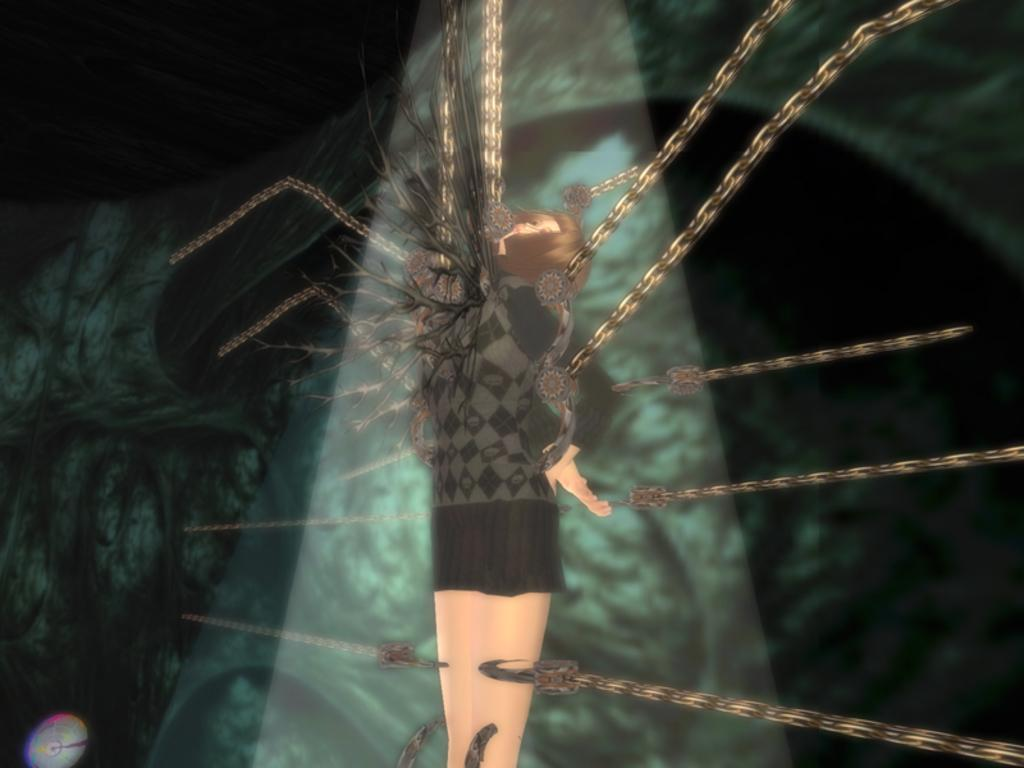What type of image is in the picture? There is an animated image of a woman in the picture. What is the woman doing in the image? The woman is standing in the image. Is the woman bound or restricted in any way? Yes, the woman is tied with chains in the image. How many geese are visible in the image? There are no geese present in the image; it features an animated woman standing and tied with chains. What type of tooth is the woman using to cut the chains in the image? There is no tooth present in the image, and the woman is not using any tool to cut the chains. 